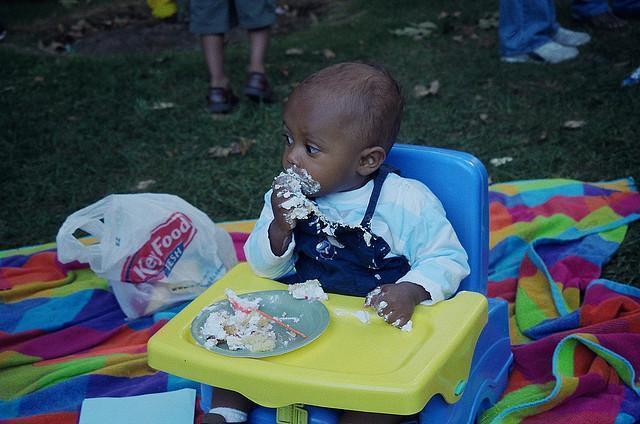Why is this person so messy?
Make your selection and explain in format: 'Answer: answer
Rationale: rationale.'
Options: Is misbehaving, bad manners, baby, is blind. Answer: baby.
Rationale: The little tyke doesn't even know he's being messy. 